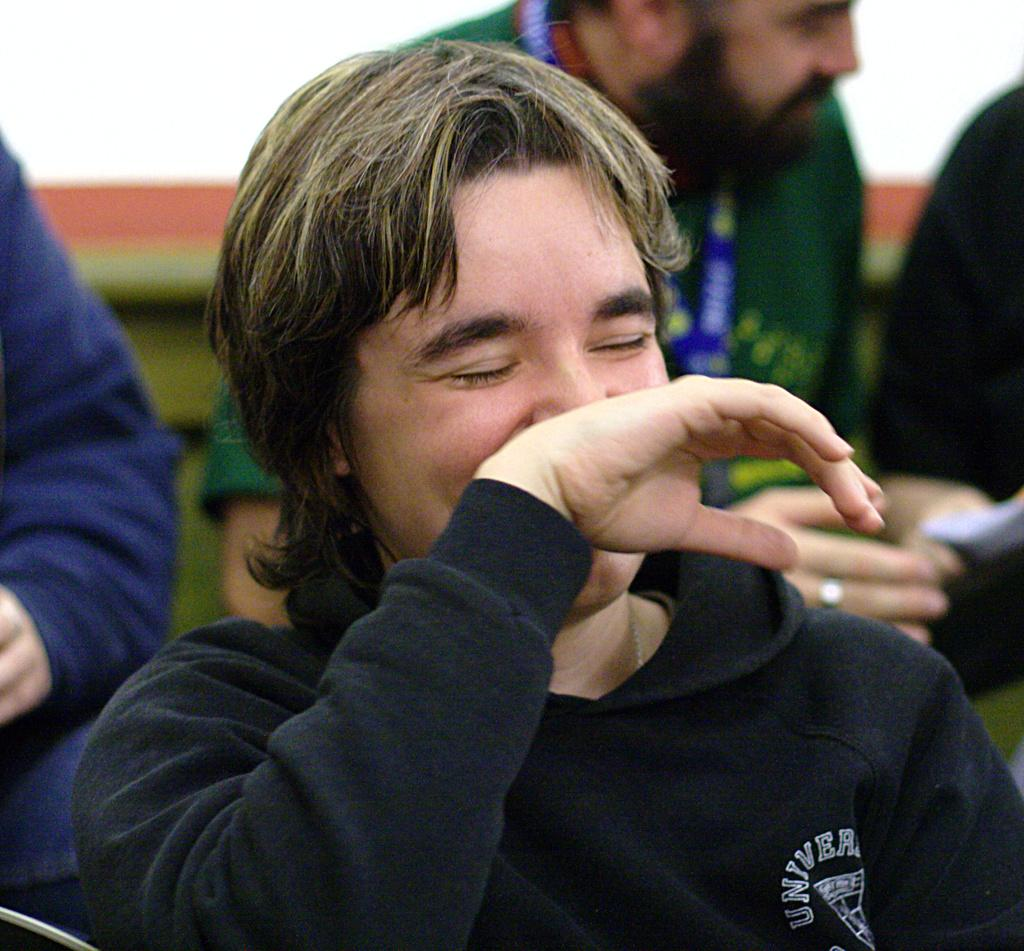What is the main subject of the image? The main subject of the image is a man. What is the man doing in the image? The man is smiling in the image. What is the man wearing in the image? The man is wearing a black t-shirt in the image. Can you describe the background of the image? There are people in the background of the image. How many boys are playing with the cat in the image? There is no cat or boys present in the image. What type of lift can be seen in the image? There is no lift present in the image. 